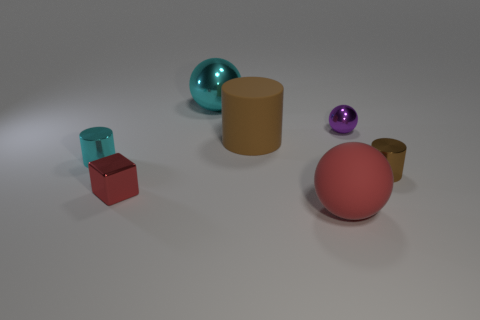Can you tell me the colors of all the objects in the picture? Certainly! In the picture, we have objects in the following colors: red, blue, aqua, yellow, purple, and two shades of brown.  Which object stands out the most to you, and why? The aqua-colored sphere stands out due to its vibrant color and reflective surface, which contrasts with the more subdued and matte finishes of the other objects. 